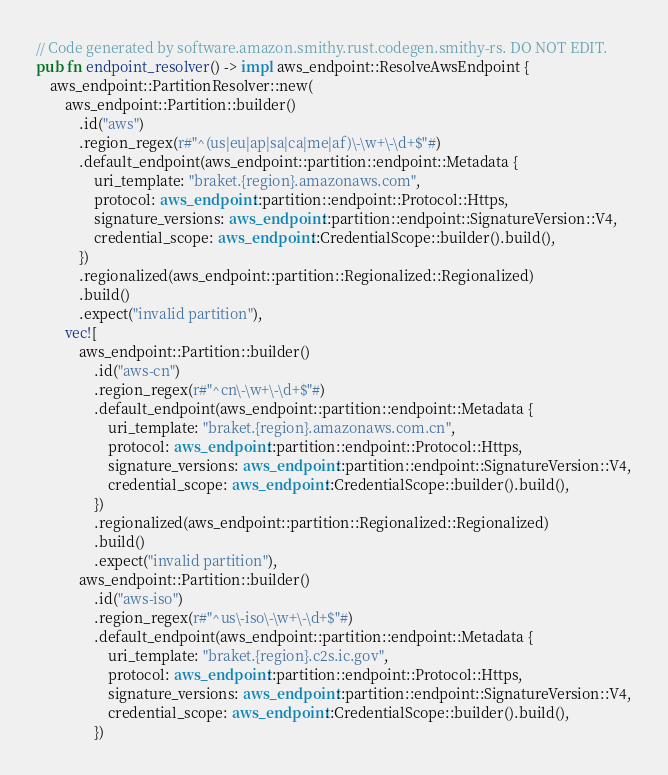<code> <loc_0><loc_0><loc_500><loc_500><_Rust_>// Code generated by software.amazon.smithy.rust.codegen.smithy-rs. DO NOT EDIT.
pub fn endpoint_resolver() -> impl aws_endpoint::ResolveAwsEndpoint {
    aws_endpoint::PartitionResolver::new(
        aws_endpoint::Partition::builder()
            .id("aws")
            .region_regex(r#"^(us|eu|ap|sa|ca|me|af)\-\w+\-\d+$"#)
            .default_endpoint(aws_endpoint::partition::endpoint::Metadata {
                uri_template: "braket.{region}.amazonaws.com",
                protocol: aws_endpoint::partition::endpoint::Protocol::Https,
                signature_versions: aws_endpoint::partition::endpoint::SignatureVersion::V4,
                credential_scope: aws_endpoint::CredentialScope::builder().build(),
            })
            .regionalized(aws_endpoint::partition::Regionalized::Regionalized)
            .build()
            .expect("invalid partition"),
        vec![
            aws_endpoint::Partition::builder()
                .id("aws-cn")
                .region_regex(r#"^cn\-\w+\-\d+$"#)
                .default_endpoint(aws_endpoint::partition::endpoint::Metadata {
                    uri_template: "braket.{region}.amazonaws.com.cn",
                    protocol: aws_endpoint::partition::endpoint::Protocol::Https,
                    signature_versions: aws_endpoint::partition::endpoint::SignatureVersion::V4,
                    credential_scope: aws_endpoint::CredentialScope::builder().build(),
                })
                .regionalized(aws_endpoint::partition::Regionalized::Regionalized)
                .build()
                .expect("invalid partition"),
            aws_endpoint::Partition::builder()
                .id("aws-iso")
                .region_regex(r#"^us\-iso\-\w+\-\d+$"#)
                .default_endpoint(aws_endpoint::partition::endpoint::Metadata {
                    uri_template: "braket.{region}.c2s.ic.gov",
                    protocol: aws_endpoint::partition::endpoint::Protocol::Https,
                    signature_versions: aws_endpoint::partition::endpoint::SignatureVersion::V4,
                    credential_scope: aws_endpoint::CredentialScope::builder().build(),
                })</code> 